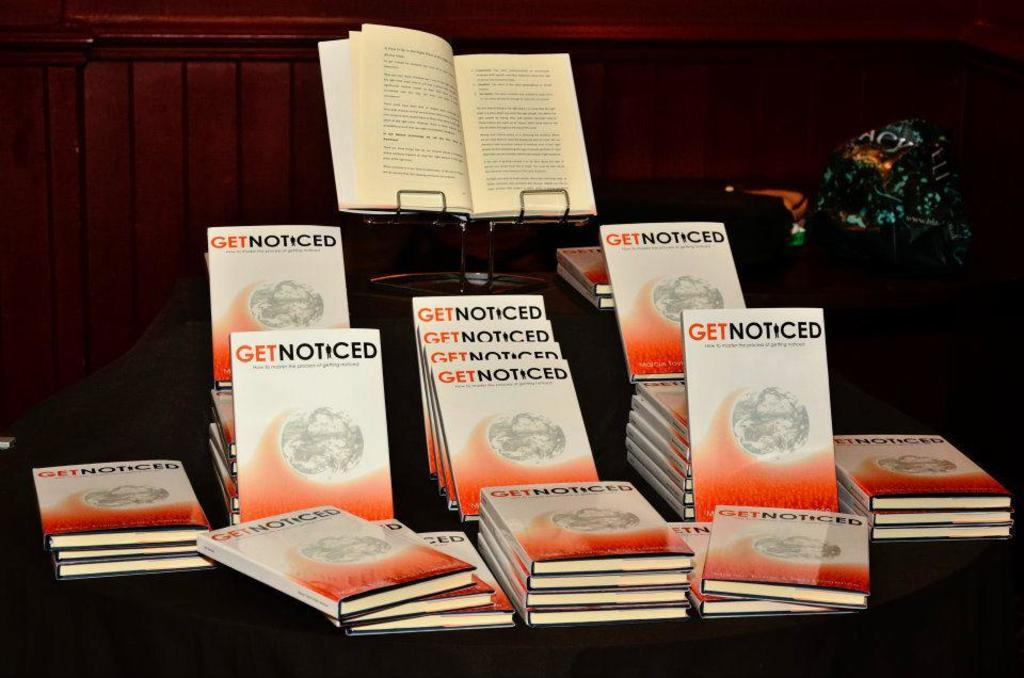<image>
Give a short and clear explanation of the subsequent image. The book Get Noticed is on display on a table, one copy open on a stand. 